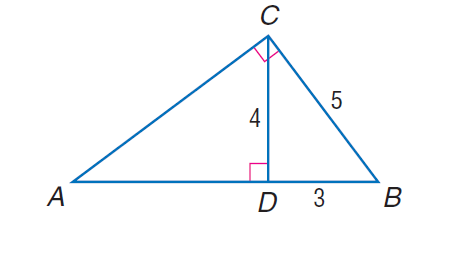Answer the mathemtical geometry problem and directly provide the correct option letter.
Question: Find the perimeter of the given triangle. \triangle A B C, if \triangle A B C \sim \triangle C B D, C D = 4, D B = 3, and C B = 5.
Choices: A: 15 B: 16 C: 18 D: 20 D 